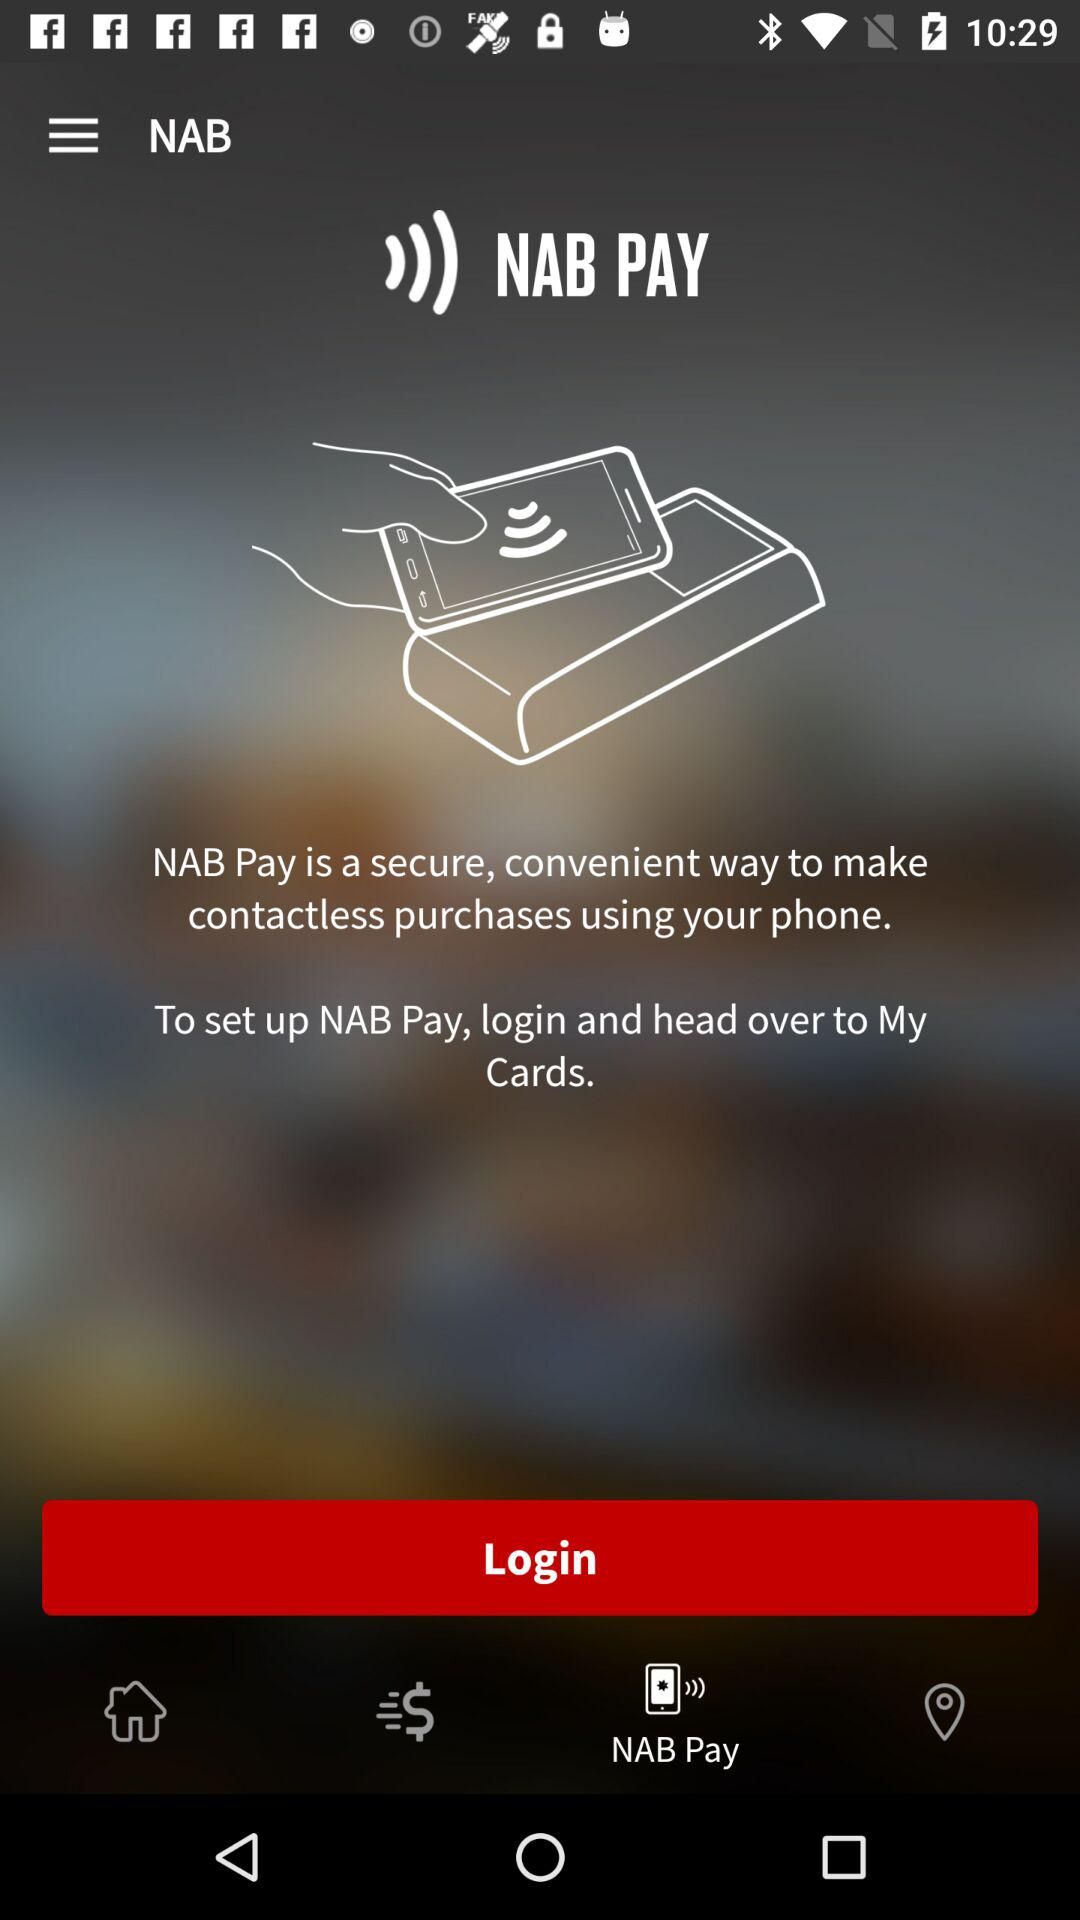What is the version of this application?
When the provided information is insufficient, respond with <no answer>. <no answer> 